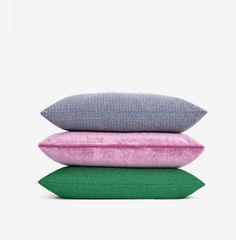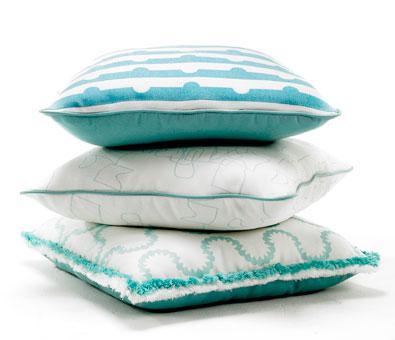The first image is the image on the left, the second image is the image on the right. Evaluate the accuracy of this statement regarding the images: "There are at most 7 pillows in the pair of images.". Is it true? Answer yes or no. Yes. The first image is the image on the left, the second image is the image on the right. For the images displayed, is the sentence "A pillow stack includes a pinkish-violet pillow the second from the bottom." factually correct? Answer yes or no. Yes. 